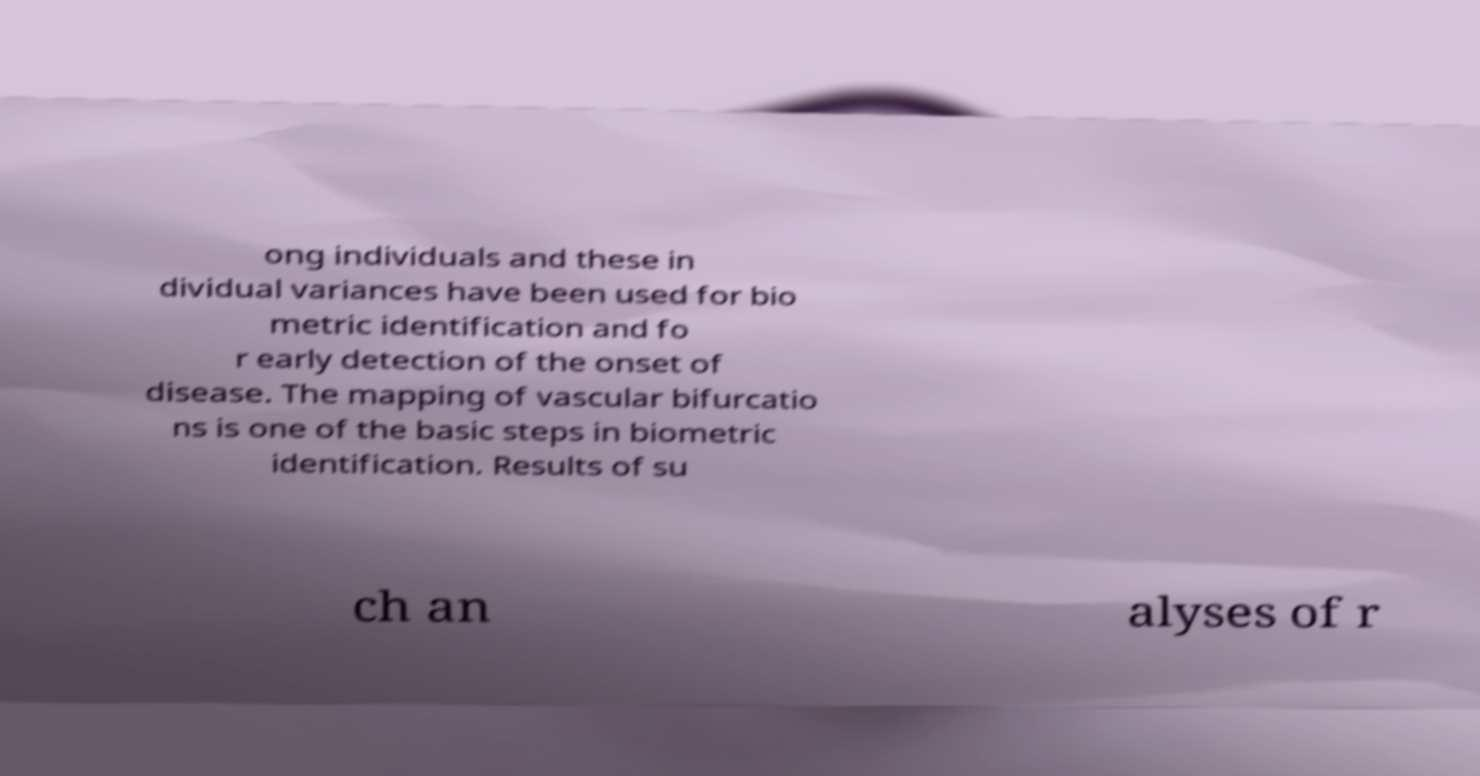Could you extract and type out the text from this image? ong individuals and these in dividual variances have been used for bio metric identification and fo r early detection of the onset of disease. The mapping of vascular bifurcatio ns is one of the basic steps in biometric identification. Results of su ch an alyses of r 